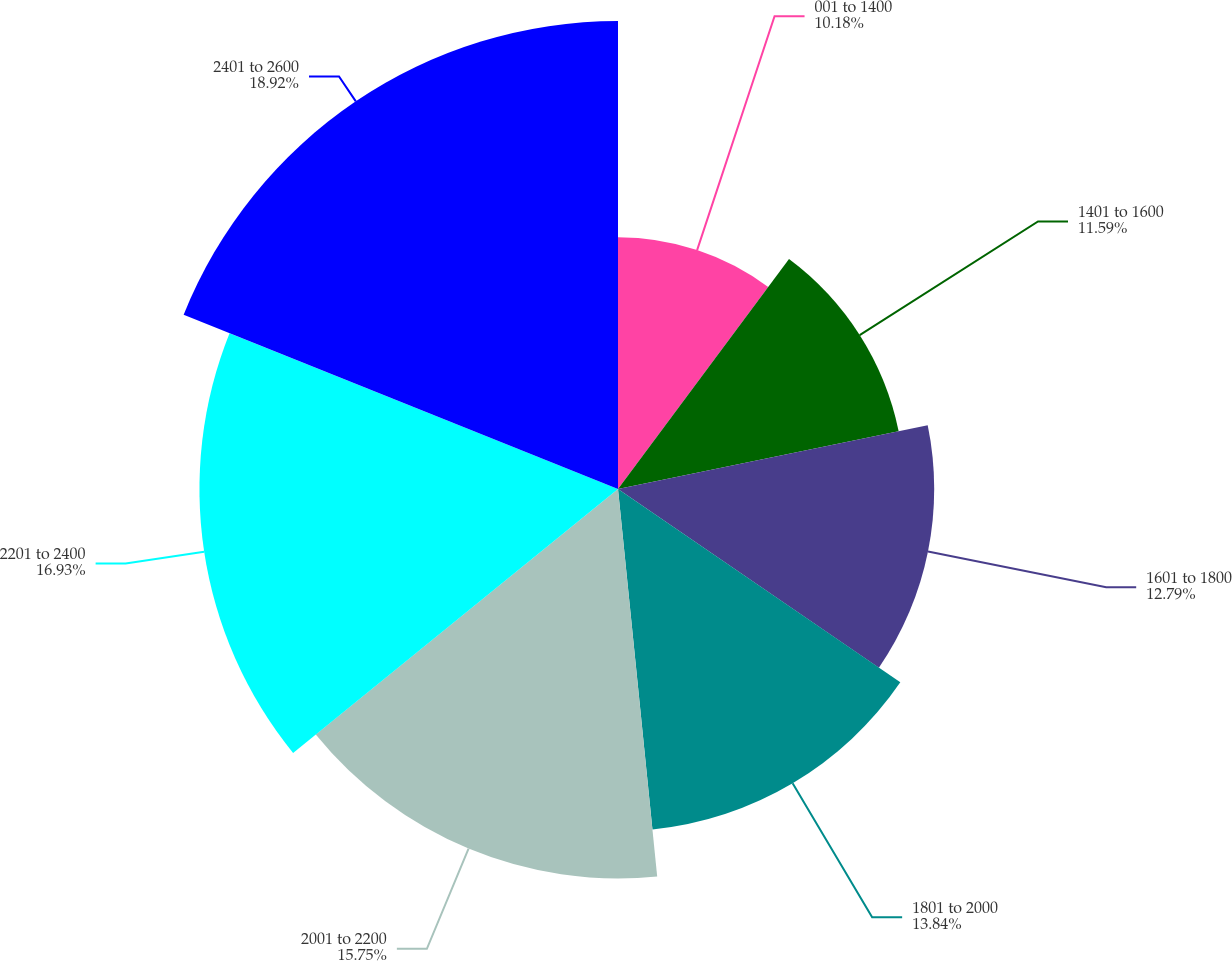Convert chart. <chart><loc_0><loc_0><loc_500><loc_500><pie_chart><fcel>001 to 1400<fcel>1401 to 1600<fcel>1601 to 1800<fcel>1801 to 2000<fcel>2001 to 2200<fcel>2201 to 2400<fcel>2401 to 2600<nl><fcel>10.18%<fcel>11.59%<fcel>12.79%<fcel>13.84%<fcel>15.75%<fcel>16.93%<fcel>18.93%<nl></chart> 